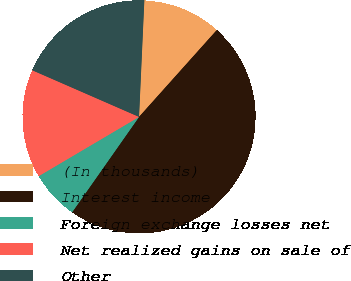<chart> <loc_0><loc_0><loc_500><loc_500><pie_chart><fcel>(In thousands)<fcel>Interest income<fcel>Foreign exchange losses net<fcel>Net realized gains on sale of<fcel>Other<nl><fcel>10.9%<fcel>48.12%<fcel>6.77%<fcel>15.04%<fcel>19.17%<nl></chart> 